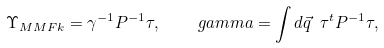<formula> <loc_0><loc_0><loc_500><loc_500>\Upsilon _ { M M F k } = \gamma ^ { - 1 } P ^ { - 1 } \tau , \quad g a m m a = \int d \vec { q } \ \tau ^ { t } P ^ { - 1 } \tau ,</formula> 